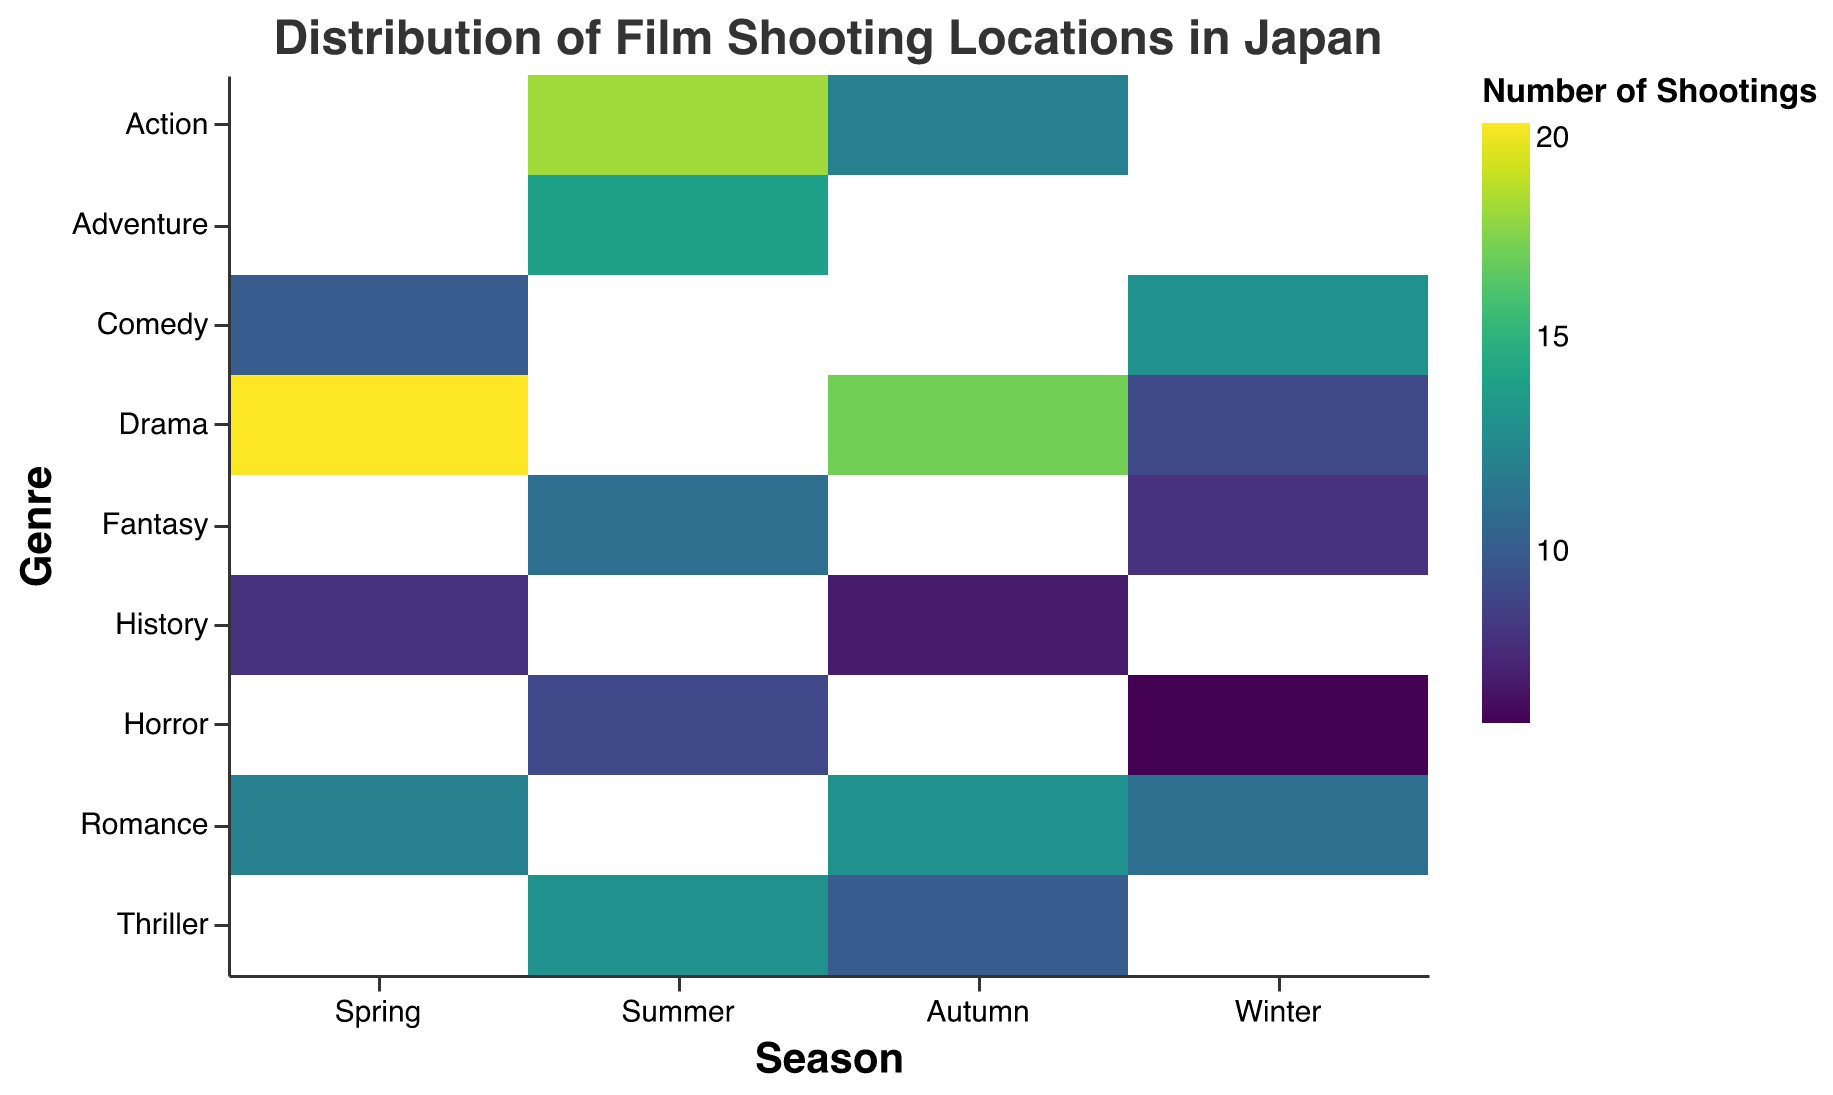What is the title of the heatmap? The title is usually placed at the top of the chart and serves to provide a brief description of what the figure represents. In this case, it is labeled "Distribution of Film Shooting Locations in Japan".
Answer: Distribution of Film Shooting Locations in Japan Which season has the highest number of shootings for Drama? By observing the color intensity in the heatmap for the Drama genre across different seasons, we identify the darkest color under Spring, which implies the highest number. Referring to the tooltip, Spring-Drama has 20 shootings.
Answer: Spring How many Romance films were shot in Hokkaido during Autumn? Locate the intersection of Autumn and Romance, then use the tooltip or color intensity to find the number of shootings, which is 13.
Answer: 13 Which season has the least number of Horror shootings? By comparing the color intensities for the Horror genre across all seasons, Winter is the lightest, indicating the fewest shootings. The tooltip confirms Winter-Horror has 6 shootings.
Answer: Winter Which genre had the highest number of shootings in Summer? Compare the color intensities of all genres in Summer. Action has the darkest color indicating 18 shootings.
Answer: Action What is the total number of film shootings recorded in Autumn? Sum the number of shootings for each genre in Autumn. Drama (17), Romance (13), History (7), Thriller (10), and Action (12) give a total of 59.
Answer: 59 Comparing Kyoto and Hokkaido, which location had more film shootings in total? Sum the shootings for Kyoto (Spring-Romance: 15, Autumn-Drama: 17) and Hokkaido (Summer-Adventure: 14, Autumn-Romance: 13, Winter-Romance: 11) to compare. Kyoto has 32, and Hokkaido has 38.
Answer: Hokkaido Which season and genre combination has the maximum number of shootings? By identifying the darkest cell in the heatmap, the combination Spring-Drama has the maximum shootings, which is 20.
Answer: Spring-Drama What is the average number of shootings for the Comedy genre across all seasons? Sum the number of shootings for Comedy (Spring: 10, Winter: 13) and divide by 2. The average is (10 + 13) / 2 = 11.5.
Answer: 11.5 